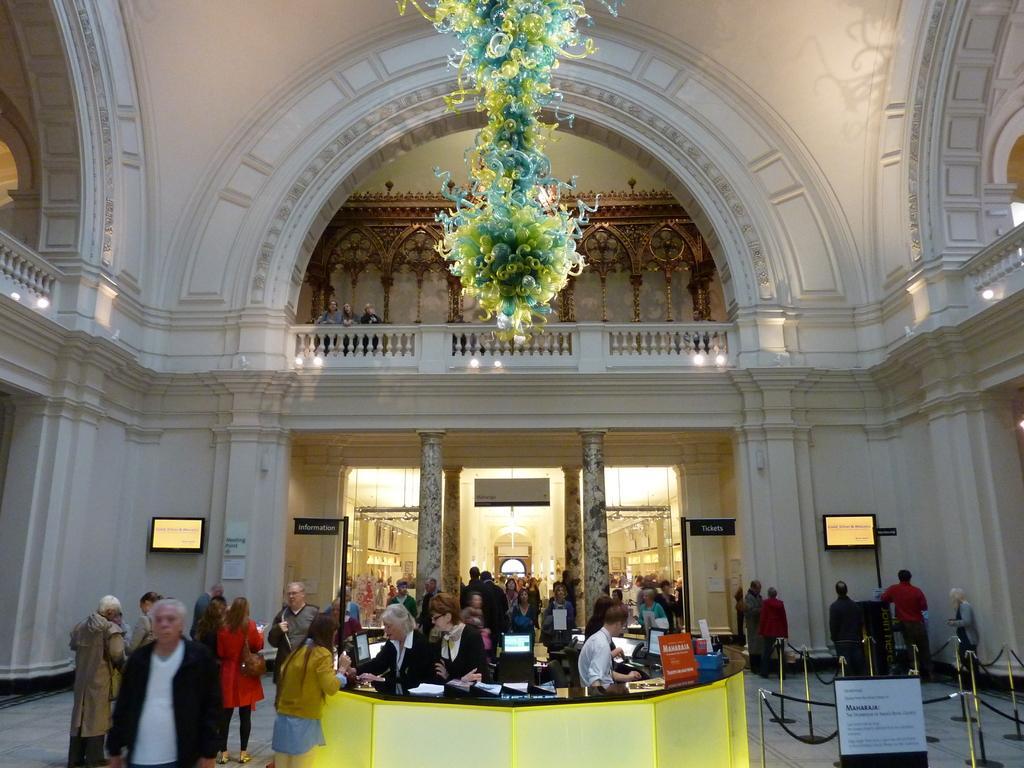Can you describe this image briefly? In this image at the bottom, there are many people, monitors, papers, posters, pillars. In the middle there are some people, lights, decorations and wall. 